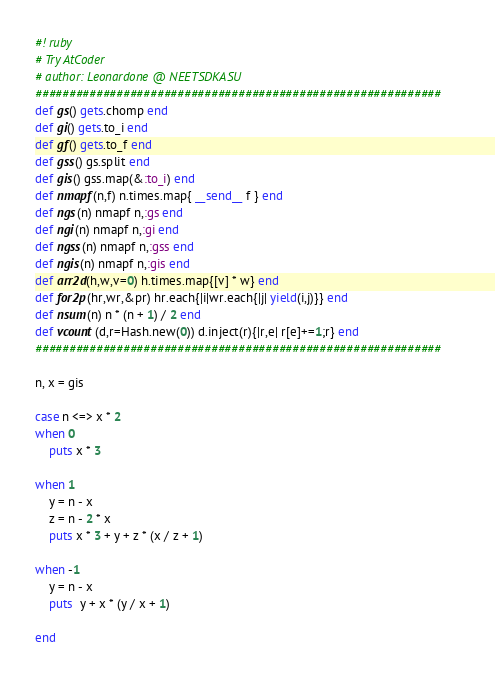Convert code to text. <code><loc_0><loc_0><loc_500><loc_500><_Ruby_>#! ruby
# Try AtCoder
# author: Leonardone @ NEETSDKASU
############################################################
def gs() gets.chomp end
def gi() gets.to_i end
def gf() gets.to_f end
def gss() gs.split end
def gis() gss.map(&:to_i) end
def nmapf(n,f) n.times.map{ __send__ f } end
def ngs(n) nmapf n,:gs end
def ngi(n) nmapf n,:gi end
def ngss(n) nmapf n,:gss end
def ngis(n) nmapf n,:gis end
def arr2d(h,w,v=0) h.times.map{[v] * w} end
def for2p(hr,wr,&pr) hr.each{|i|wr.each{|j| yield(i,j)}} end
def nsum(n) n * (n + 1) / 2 end
def vcount(d,r=Hash.new(0)) d.inject(r){|r,e| r[e]+=1;r} end
############################################################

n, x = gis

case n <=> x * 2
when 0
    puts x * 3
    
when 1
    y = n - x
    z = n - 2 * x
    puts x * 3 + y + z * (x / z + 1)
    
when -1
    y = n - x
    puts  y + x * (y / x + 1)
    
end
</code> 